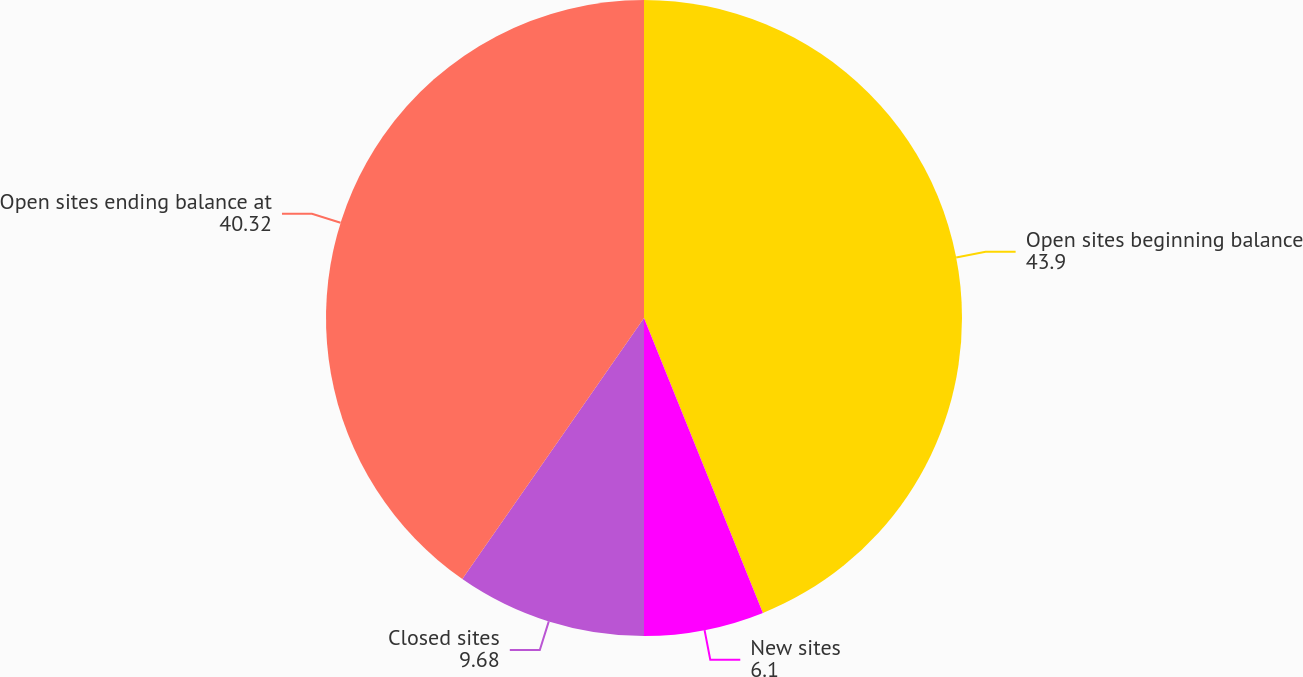<chart> <loc_0><loc_0><loc_500><loc_500><pie_chart><fcel>Open sites beginning balance<fcel>New sites<fcel>Closed sites<fcel>Open sites ending balance at<nl><fcel>43.9%<fcel>6.1%<fcel>9.68%<fcel>40.32%<nl></chart> 